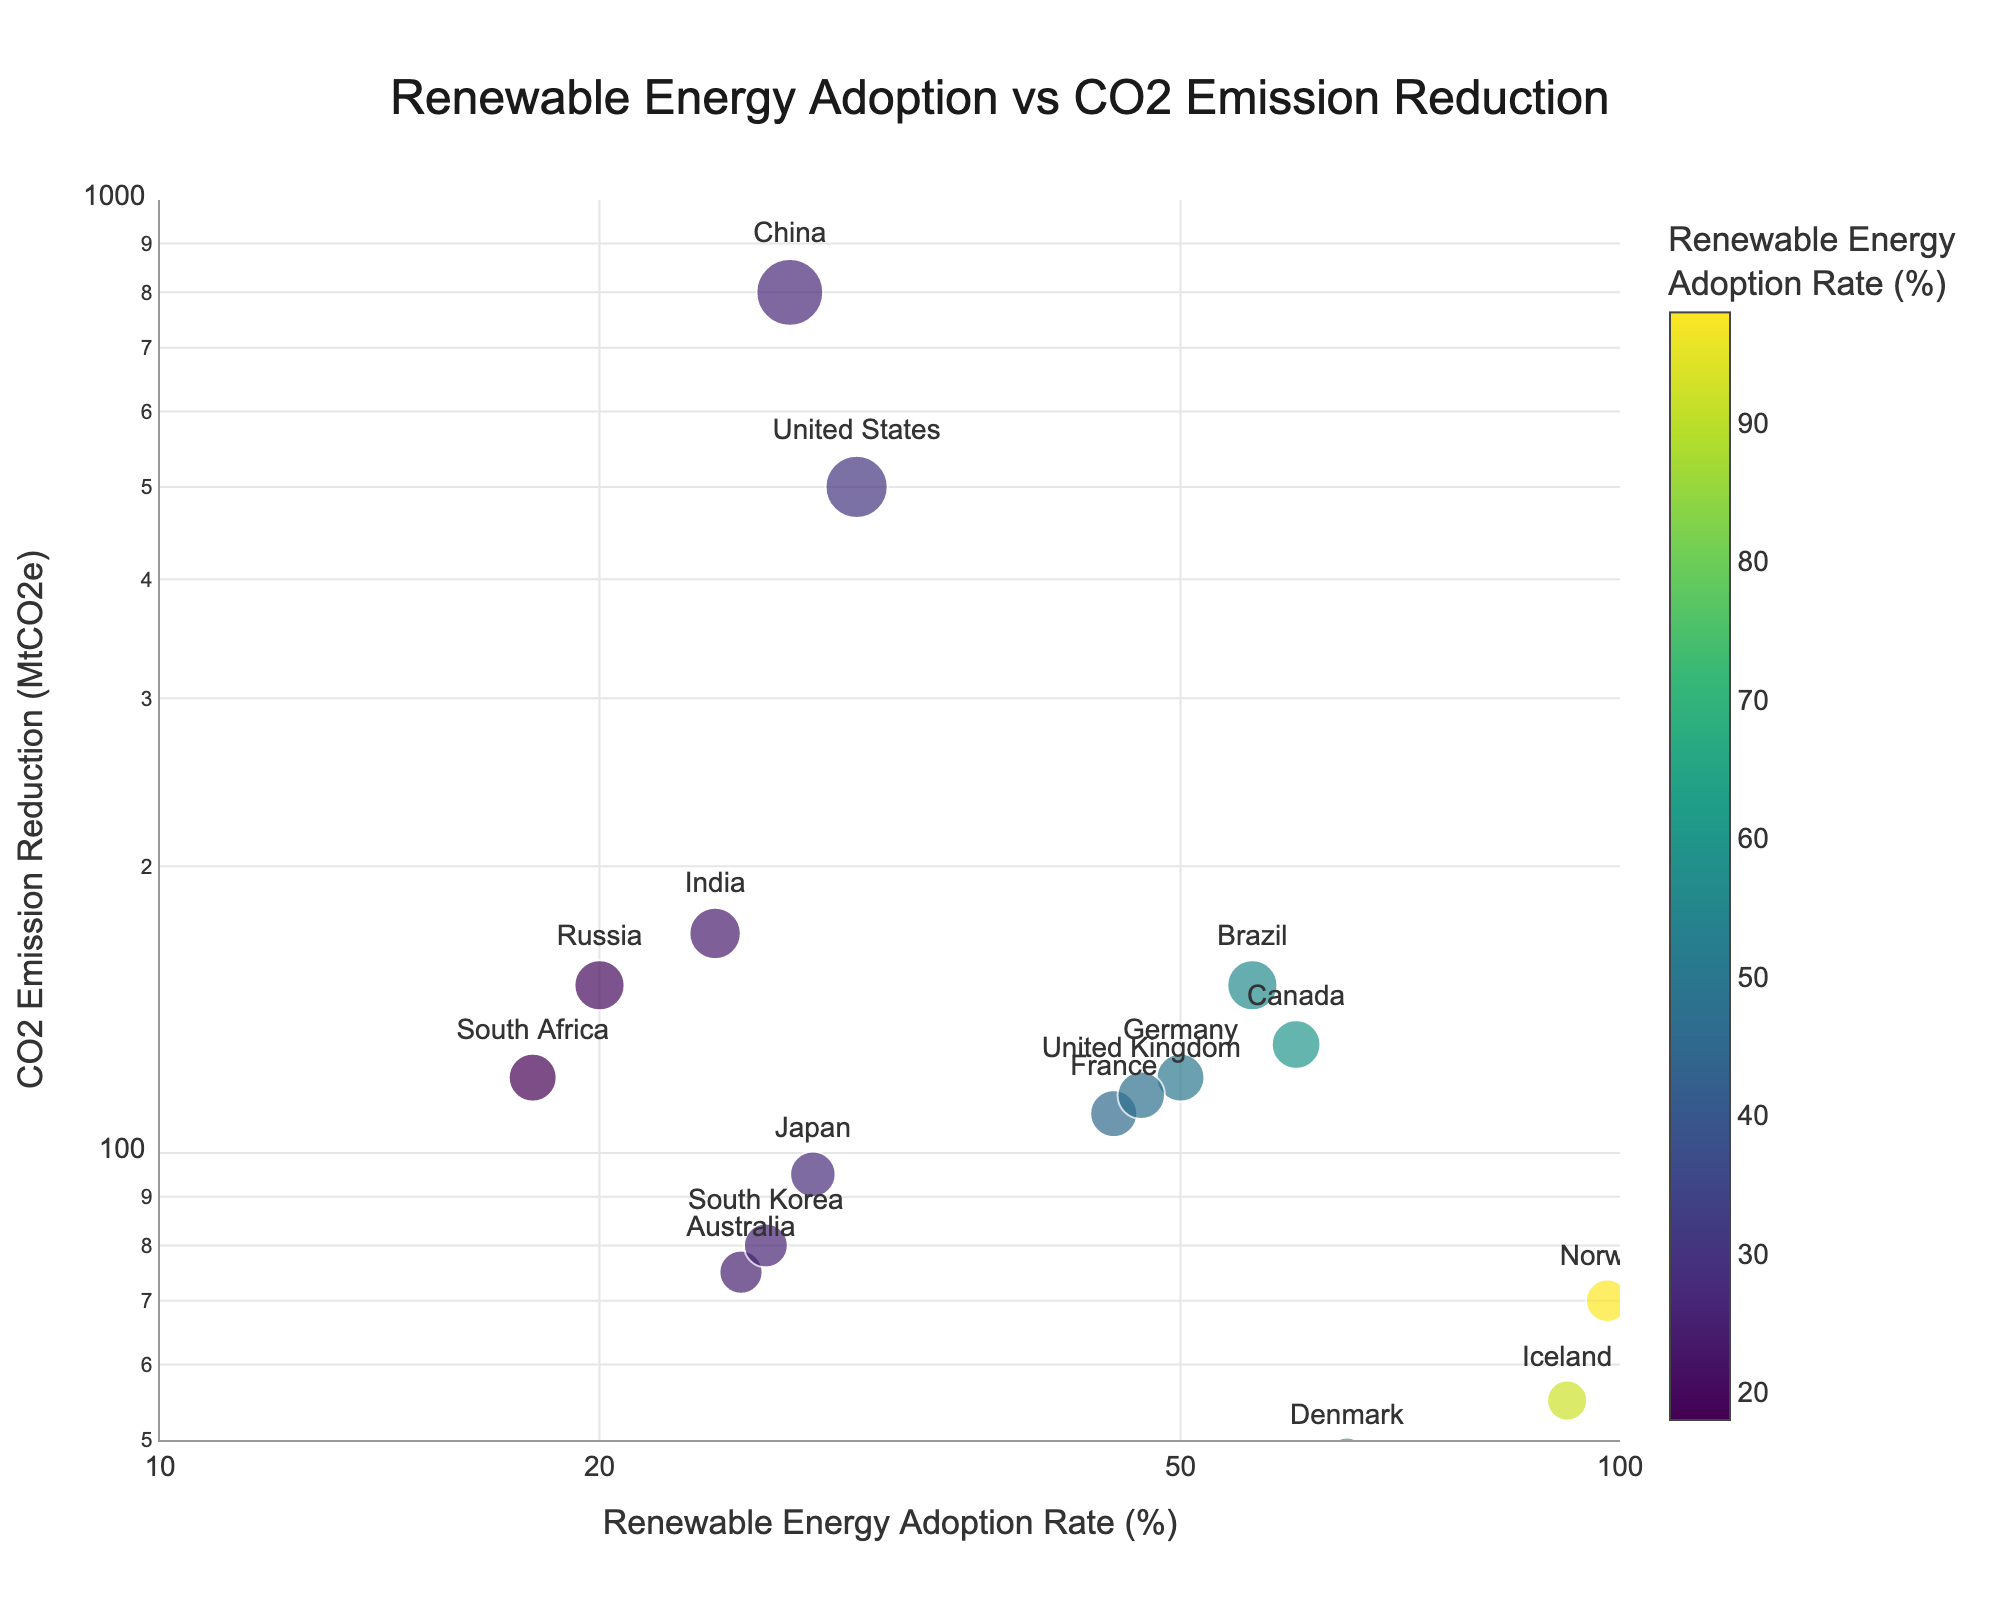What's the title of the figure? The title of the figure is positioned at the top center and is displayed in a larger font size. It reads "Renewable Energy Adoption vs CO2 Emission Reduction".
Answer: Renewable Energy Adoption vs CO2 Emission Reduction How many countries are represented in the figure? Each country is marked with a text label in the scatter plot. By counting all unique text labels, we can see that there are 16 countries.
Answer: 16 Which country has the highest renewable energy adoption rate? To find the country with the highest renewable energy adoption rate, we look for the point farthest to the right on the x-axis. This point corresponds to Norway with a rate of 98%.
Answer: Norway What is the CO2 emission reduction for China? Locate China in the plot, and check the y-axis value it corresponds to. China's CO2 emission reduction is marked at 800 MtCO2e.
Answer: 800 MtCO2e What range is used for the x-axis and y-axis? The range for the x-axis is from approximately 10% to 100% (log scale), and the range for the y-axis is from 50 MtCO2e to 1000 MtCO2e (log scale).
Answer: 10% to 100% (x-axis), 50 MtCO2e to 1000 MtCO2e (y-axis) Which countries achieved more than 100 MtCO2e CO2 emission reduction? Check the y-axis to identify points above 100 MtCO2e, then read the country labels such as Germany (120), France (110), United States (500), China (800), Brazil (150), South Africa (120), Canada (130), and Russia (150).
Answer: Germany, France, United States, China, Brazil, South Africa, Canada, Russia Which country has a similar CO2 emission reduction as France but a lower renewable energy adoption rate? France has a CO2 emission reduction of 110 MtCO2e. Locate other points near 110 on the y-axis with lower x-axis values. The United Kingdom (115) fits this criterion, with a lower adoption rate of 47%.
Answer: United Kingdom Does a higher renewable energy adoption rate always correspond to a higher CO2 emission reduction? No, this is not always the case. For example, Norway has the highest adoption rate (98%) with a lower CO2 reduction (70 MtCO2e) compared to China, which has a much lower adoption rate (27%) but a higher reduction (800 MtCO2e).
Answer: No Which country has the smallest marker size, and what does that indicate about its CO2 emission reduction? The smallest marker indicates the lowest CO2 emission reduction. South Africa, with 18% renewable adoption, has one of the smaller markers, corresponding to a CO2 reduction of 120 MtCO2e.
Answer: South Africa Compare the renewable energy adoption rates and CO2 emission reductions of India and Australia. India has a renewable energy adoption rate of 24% and a CO2 emission reduction of 170 MtCO2e. Australia has a higher adoption rate of 25% but a lower reduction of 75 MtCO2e.
Answer: India: 24%, 170 MtCO2e; Australia: 25%, 75 MtCO2e 